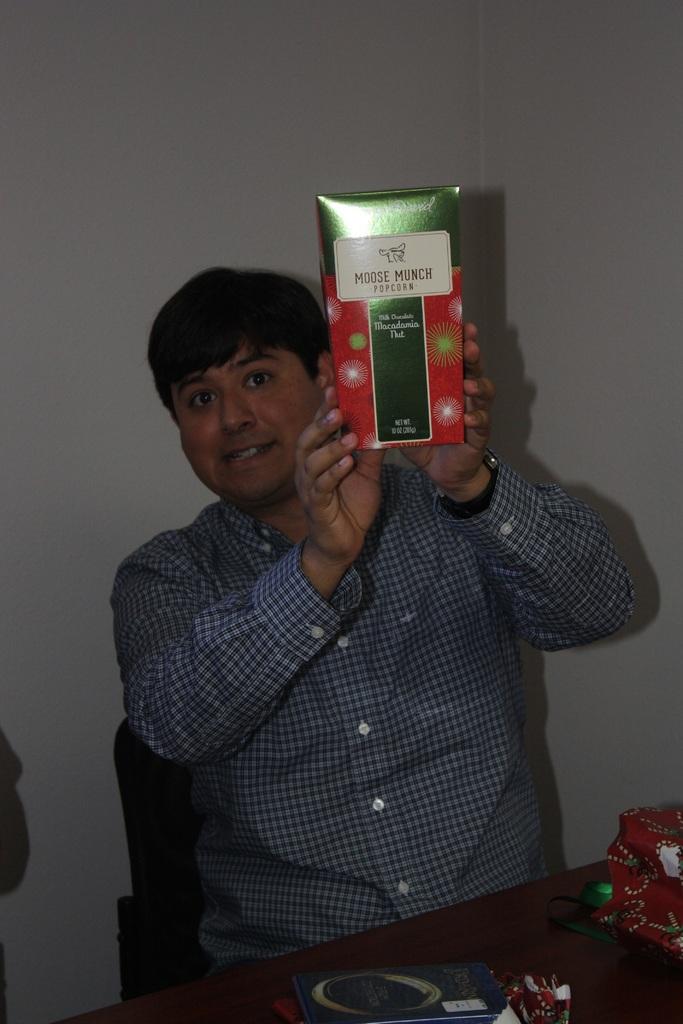What type of snack is in the red and green box?
Make the answer very short. Popcorn. 